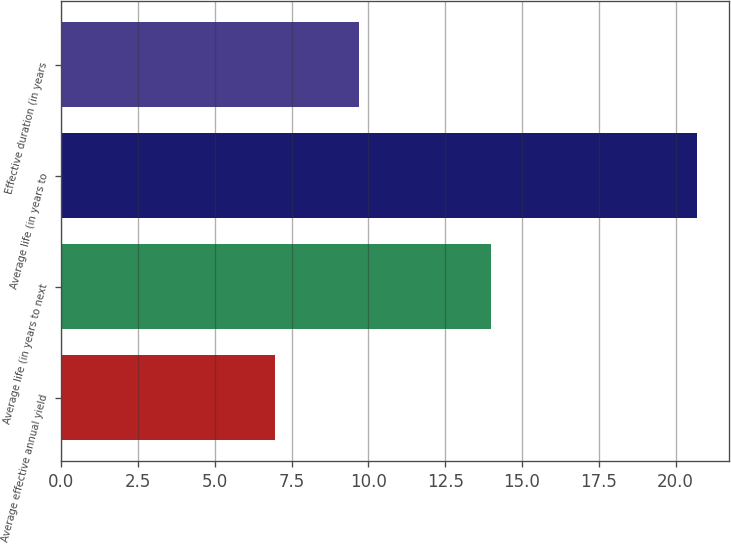Convert chart. <chart><loc_0><loc_0><loc_500><loc_500><bar_chart><fcel>Average effective annual yield<fcel>Average life (in years to next<fcel>Average life (in years to<fcel>Effective duration (in years<nl><fcel>6.96<fcel>14<fcel>20.7<fcel>9.7<nl></chart> 